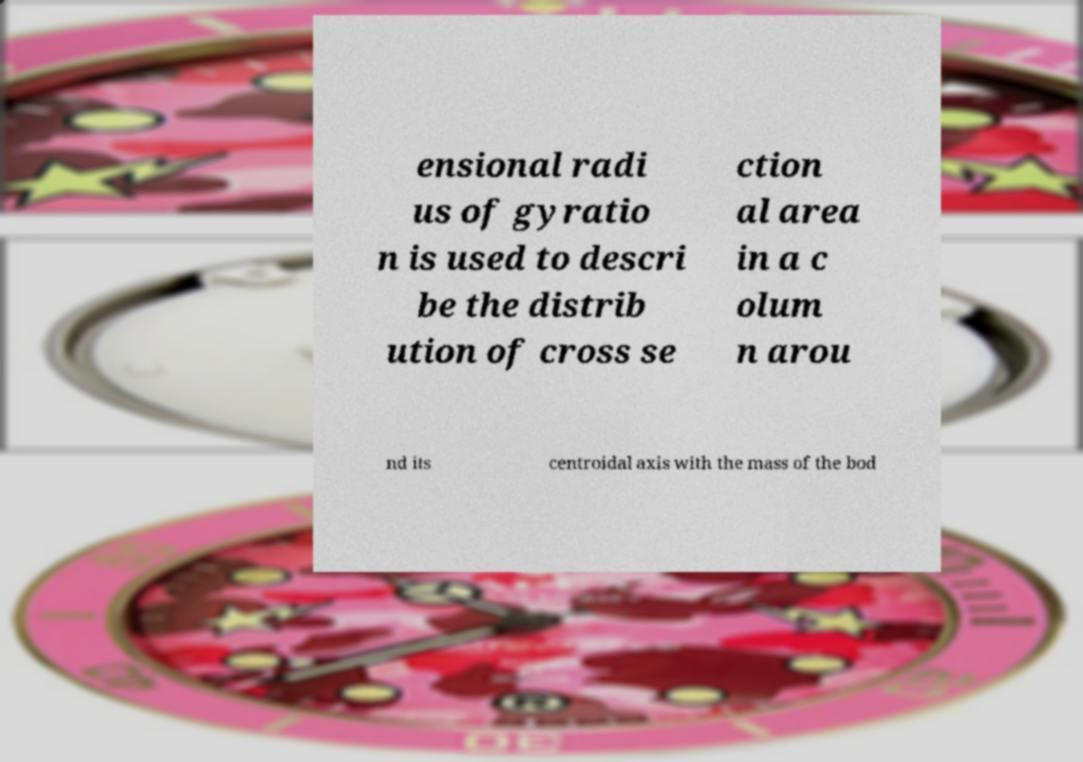What messages or text are displayed in this image? I need them in a readable, typed format. ensional radi us of gyratio n is used to descri be the distrib ution of cross se ction al area in a c olum n arou nd its centroidal axis with the mass of the bod 